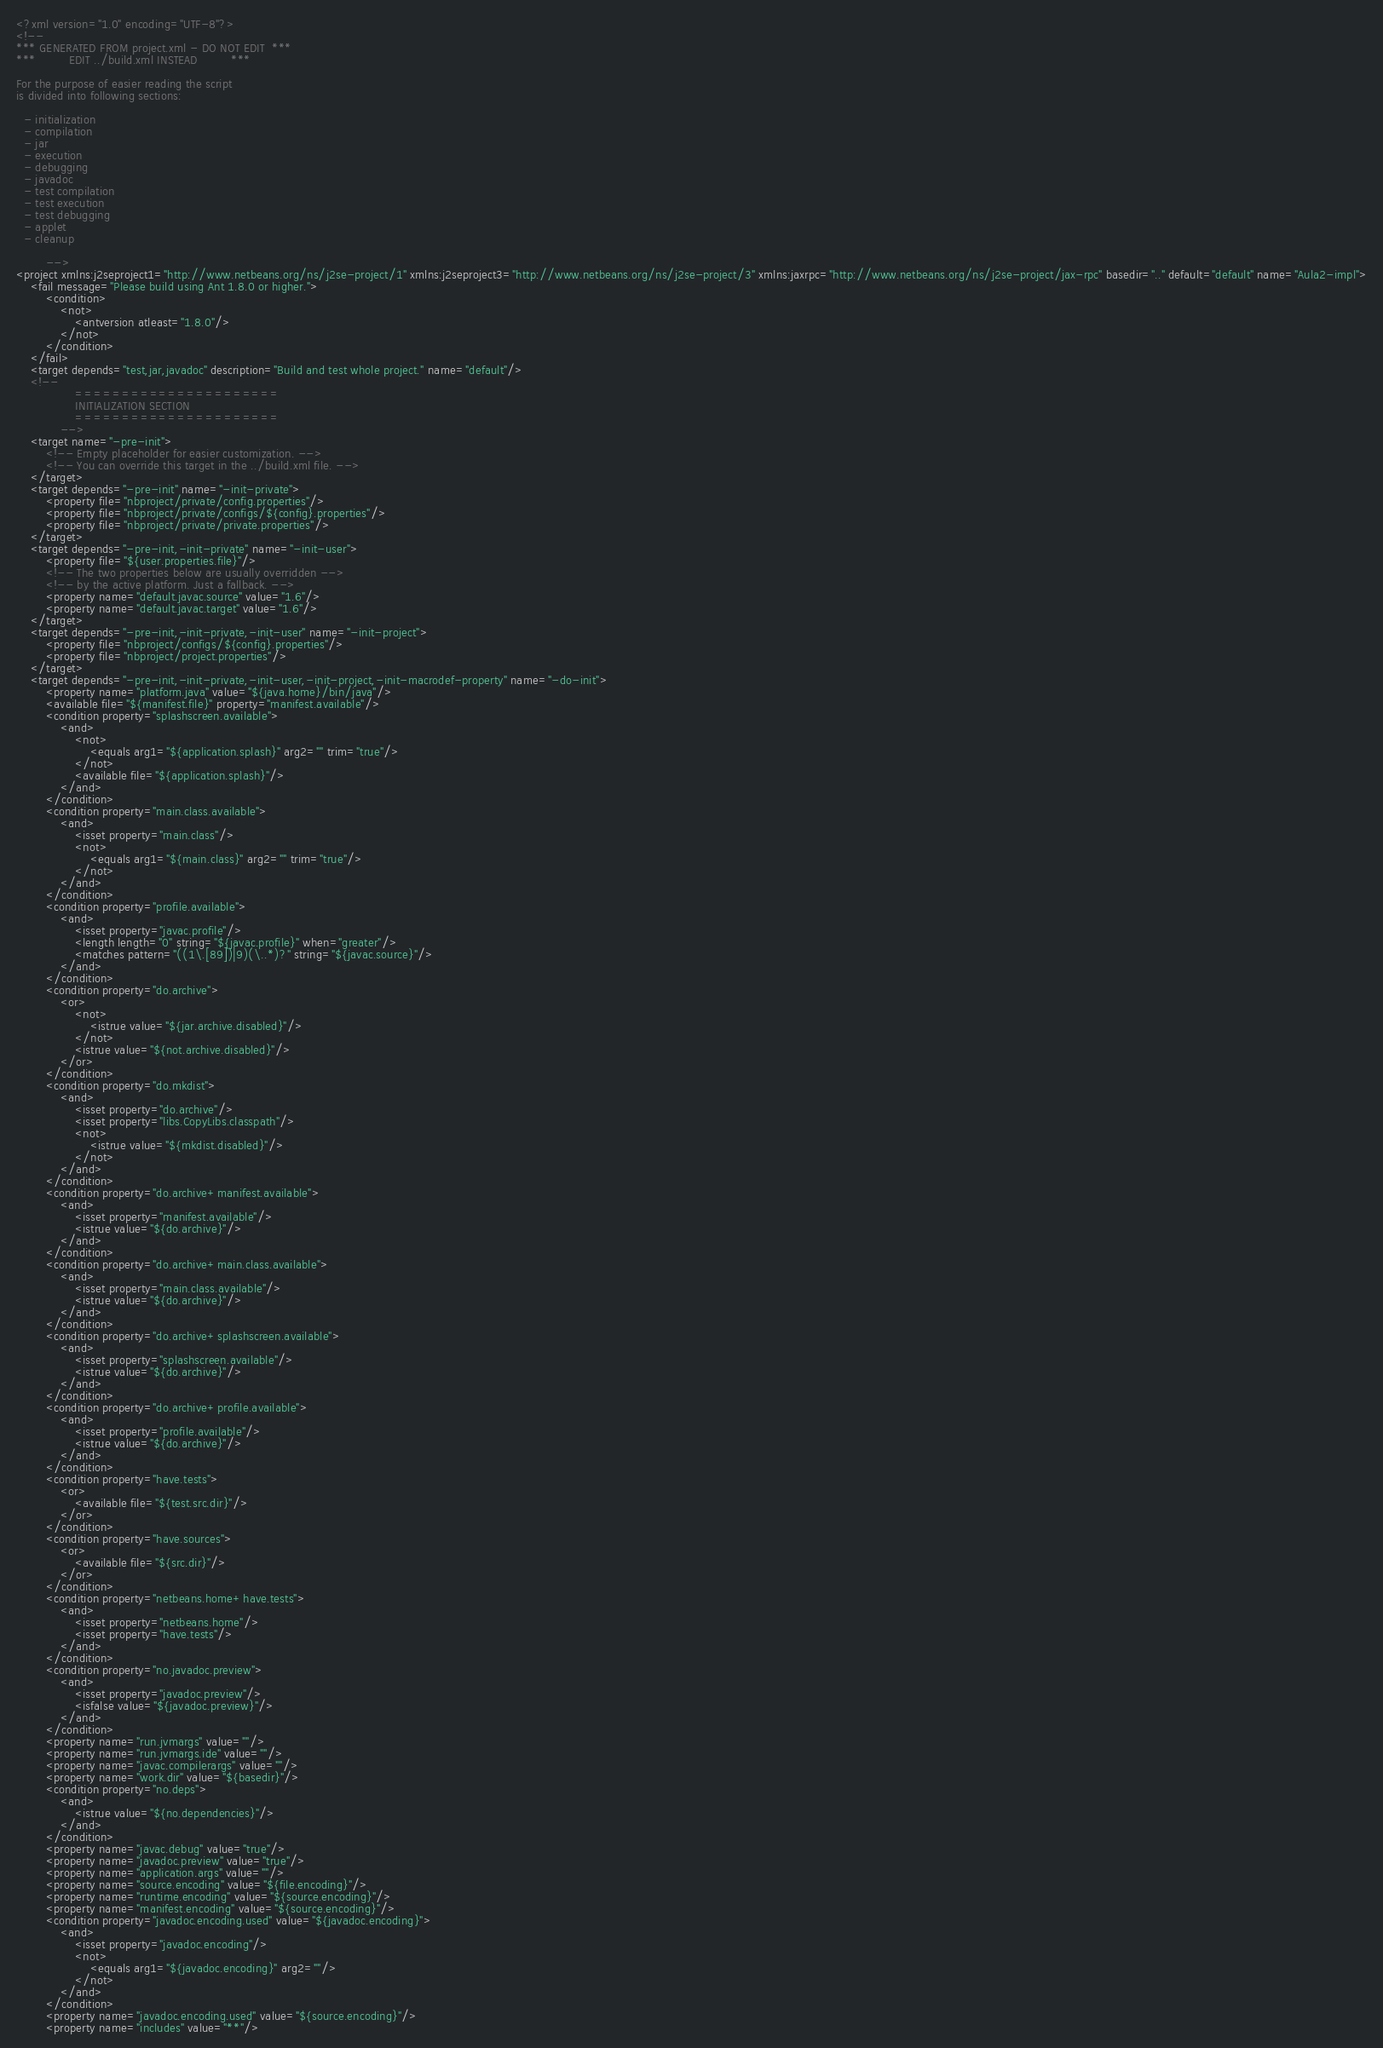<code> <loc_0><loc_0><loc_500><loc_500><_XML_><?xml version="1.0" encoding="UTF-8"?>
<!--
*** GENERATED FROM project.xml - DO NOT EDIT  ***
***         EDIT ../build.xml INSTEAD         ***

For the purpose of easier reading the script
is divided into following sections:

  - initialization
  - compilation
  - jar
  - execution
  - debugging
  - javadoc
  - test compilation
  - test execution
  - test debugging
  - applet
  - cleanup

        -->
<project xmlns:j2seproject1="http://www.netbeans.org/ns/j2se-project/1" xmlns:j2seproject3="http://www.netbeans.org/ns/j2se-project/3" xmlns:jaxrpc="http://www.netbeans.org/ns/j2se-project/jax-rpc" basedir=".." default="default" name="Aula2-impl">
    <fail message="Please build using Ant 1.8.0 or higher.">
        <condition>
            <not>
                <antversion atleast="1.8.0"/>
            </not>
        </condition>
    </fail>
    <target depends="test,jar,javadoc" description="Build and test whole project." name="default"/>
    <!-- 
                ======================
                INITIALIZATION SECTION 
                ======================
            -->
    <target name="-pre-init">
        <!-- Empty placeholder for easier customization. -->
        <!-- You can override this target in the ../build.xml file. -->
    </target>
    <target depends="-pre-init" name="-init-private">
        <property file="nbproject/private/config.properties"/>
        <property file="nbproject/private/configs/${config}.properties"/>
        <property file="nbproject/private/private.properties"/>
    </target>
    <target depends="-pre-init,-init-private" name="-init-user">
        <property file="${user.properties.file}"/>
        <!-- The two properties below are usually overridden -->
        <!-- by the active platform. Just a fallback. -->
        <property name="default.javac.source" value="1.6"/>
        <property name="default.javac.target" value="1.6"/>
    </target>
    <target depends="-pre-init,-init-private,-init-user" name="-init-project">
        <property file="nbproject/configs/${config}.properties"/>
        <property file="nbproject/project.properties"/>
    </target>
    <target depends="-pre-init,-init-private,-init-user,-init-project,-init-macrodef-property" name="-do-init">
        <property name="platform.java" value="${java.home}/bin/java"/>
        <available file="${manifest.file}" property="manifest.available"/>
        <condition property="splashscreen.available">
            <and>
                <not>
                    <equals arg1="${application.splash}" arg2="" trim="true"/>
                </not>
                <available file="${application.splash}"/>
            </and>
        </condition>
        <condition property="main.class.available">
            <and>
                <isset property="main.class"/>
                <not>
                    <equals arg1="${main.class}" arg2="" trim="true"/>
                </not>
            </and>
        </condition>
        <condition property="profile.available">
            <and>
                <isset property="javac.profile"/>
                <length length="0" string="${javac.profile}" when="greater"/>
                <matches pattern="((1\.[89])|9)(\..*)?" string="${javac.source}"/>
            </and>
        </condition>
        <condition property="do.archive">
            <or>
                <not>
                    <istrue value="${jar.archive.disabled}"/>
                </not>
                <istrue value="${not.archive.disabled}"/>
            </or>
        </condition>
        <condition property="do.mkdist">
            <and>
                <isset property="do.archive"/>
                <isset property="libs.CopyLibs.classpath"/>
                <not>
                    <istrue value="${mkdist.disabled}"/>
                </not>
            </and>
        </condition>
        <condition property="do.archive+manifest.available">
            <and>
                <isset property="manifest.available"/>
                <istrue value="${do.archive}"/>
            </and>
        </condition>
        <condition property="do.archive+main.class.available">
            <and>
                <isset property="main.class.available"/>
                <istrue value="${do.archive}"/>
            </and>
        </condition>
        <condition property="do.archive+splashscreen.available">
            <and>
                <isset property="splashscreen.available"/>
                <istrue value="${do.archive}"/>
            </and>
        </condition>
        <condition property="do.archive+profile.available">
            <and>
                <isset property="profile.available"/>
                <istrue value="${do.archive}"/>
            </and>
        </condition>
        <condition property="have.tests">
            <or>
                <available file="${test.src.dir}"/>
            </or>
        </condition>
        <condition property="have.sources">
            <or>
                <available file="${src.dir}"/>
            </or>
        </condition>
        <condition property="netbeans.home+have.tests">
            <and>
                <isset property="netbeans.home"/>
                <isset property="have.tests"/>
            </and>
        </condition>
        <condition property="no.javadoc.preview">
            <and>
                <isset property="javadoc.preview"/>
                <isfalse value="${javadoc.preview}"/>
            </and>
        </condition>
        <property name="run.jvmargs" value=""/>
        <property name="run.jvmargs.ide" value=""/>
        <property name="javac.compilerargs" value=""/>
        <property name="work.dir" value="${basedir}"/>
        <condition property="no.deps">
            <and>
                <istrue value="${no.dependencies}"/>
            </and>
        </condition>
        <property name="javac.debug" value="true"/>
        <property name="javadoc.preview" value="true"/>
        <property name="application.args" value=""/>
        <property name="source.encoding" value="${file.encoding}"/>
        <property name="runtime.encoding" value="${source.encoding}"/>
        <property name="manifest.encoding" value="${source.encoding}"/>
        <condition property="javadoc.encoding.used" value="${javadoc.encoding}">
            <and>
                <isset property="javadoc.encoding"/>
                <not>
                    <equals arg1="${javadoc.encoding}" arg2=""/>
                </not>
            </and>
        </condition>
        <property name="javadoc.encoding.used" value="${source.encoding}"/>
        <property name="includes" value="**"/></code> 